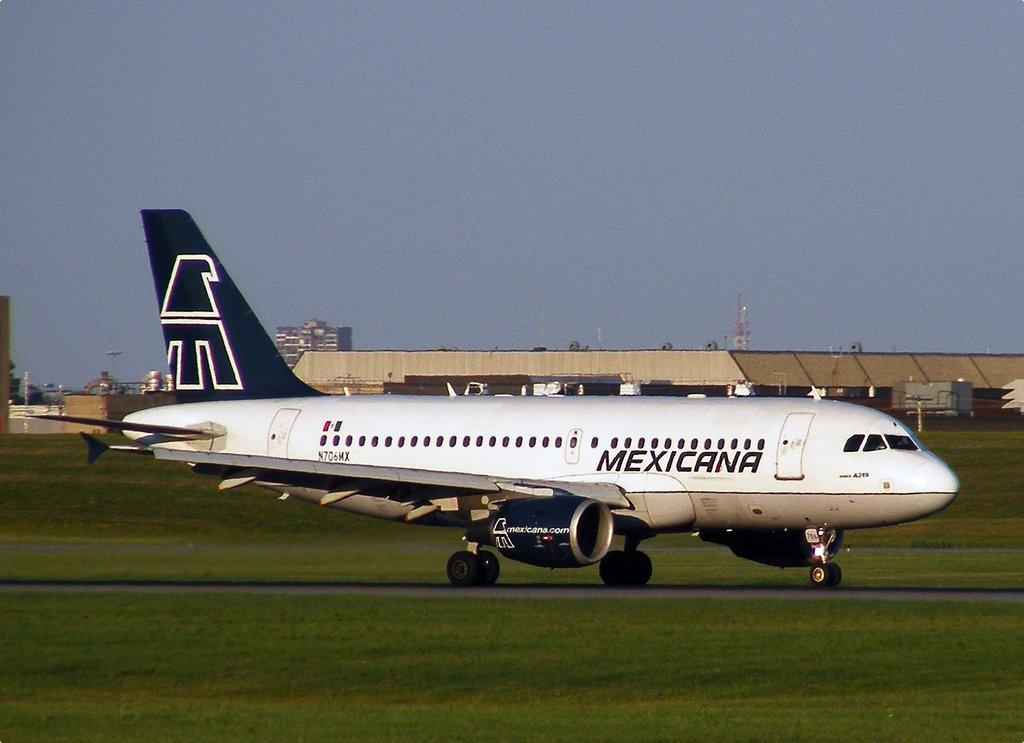What is located on the ground in the image? There is a flight on the ground in the image. What type of vegetation is present on the ground? There is grass on the ground. What can be seen in the background of the image? There are buildings in the background of the image. What is visible in the sky in the image? The sky is visible in the image. What type of ear is visible on the flight in the image? There are no ears present in the image, as it features a flight on the ground and not a living creature. 